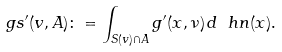<formula> <loc_0><loc_0><loc_500><loc_500>\ g s ^ { \prime } ( v , A ) \colon = \int _ { S ( v ) \cap A } g ^ { \prime } ( x , \nu ) \, d \ h n ( x ) .</formula> 